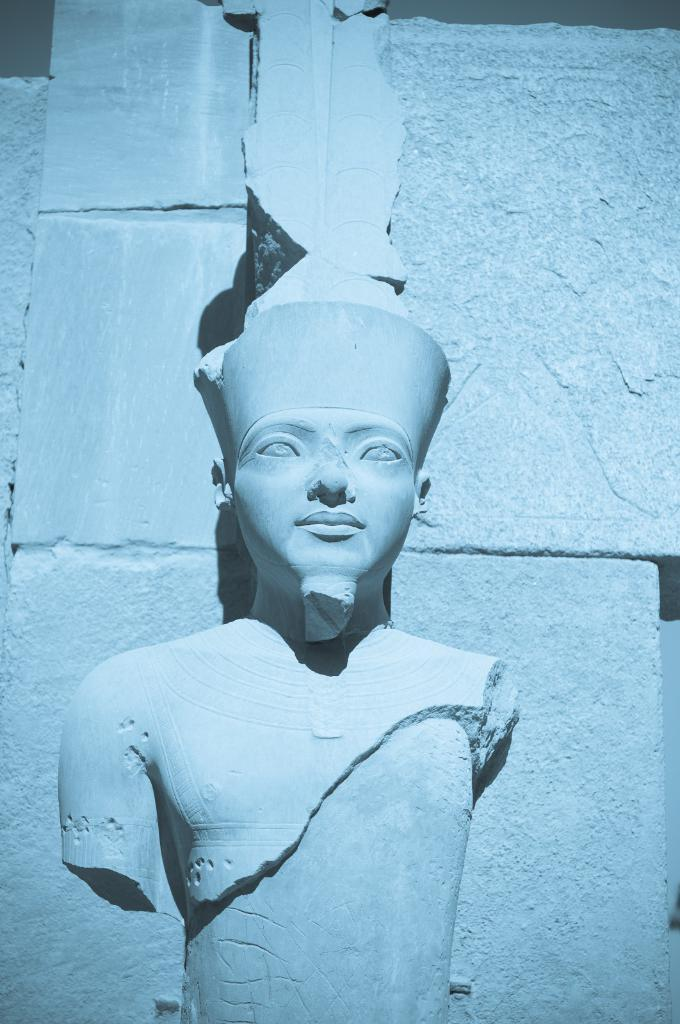What is the main subject being depicted in the image? There is a statue being carved in the image. Where is the statue being carved? The statue is being carved on a wall. Can you hear the discussion between the bee and the brothers in the image? There is no discussion between a bee and any brothers present in the image; it only features a statue being carved on a wall. 